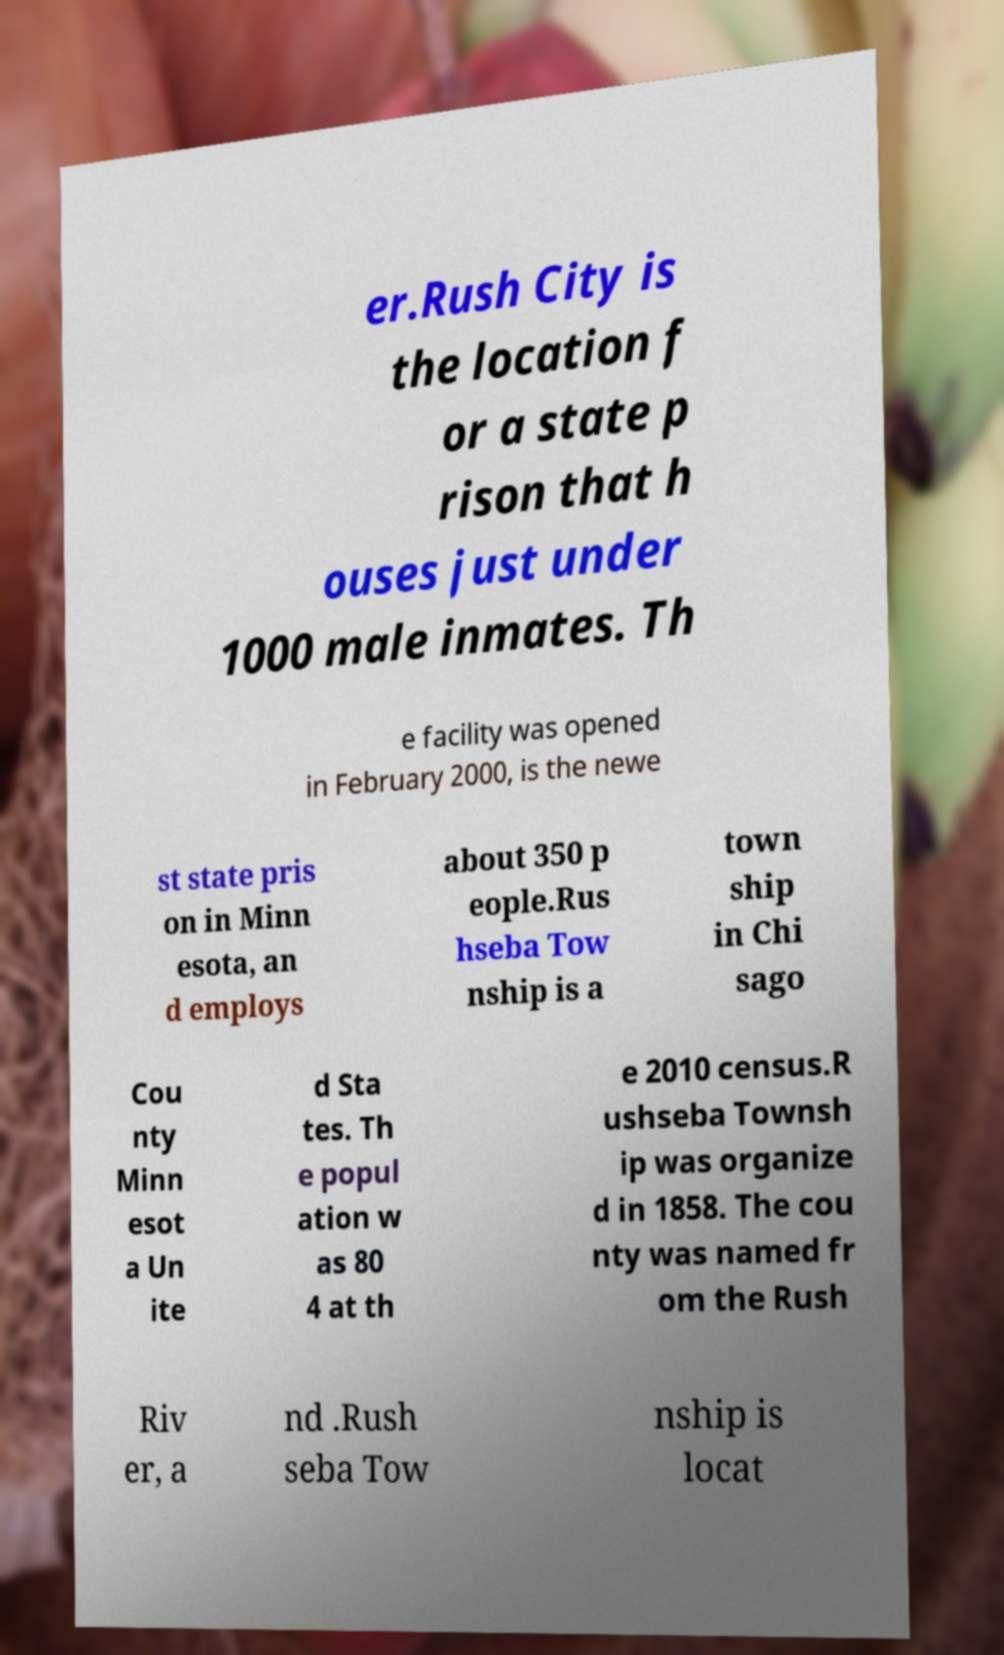There's text embedded in this image that I need extracted. Can you transcribe it verbatim? er.Rush City is the location f or a state p rison that h ouses just under 1000 male inmates. Th e facility was opened in February 2000, is the newe st state pris on in Minn esota, an d employs about 350 p eople.Rus hseba Tow nship is a town ship in Chi sago Cou nty Minn esot a Un ite d Sta tes. Th e popul ation w as 80 4 at th e 2010 census.R ushseba Townsh ip was organize d in 1858. The cou nty was named fr om the Rush Riv er, a nd .Rush seba Tow nship is locat 